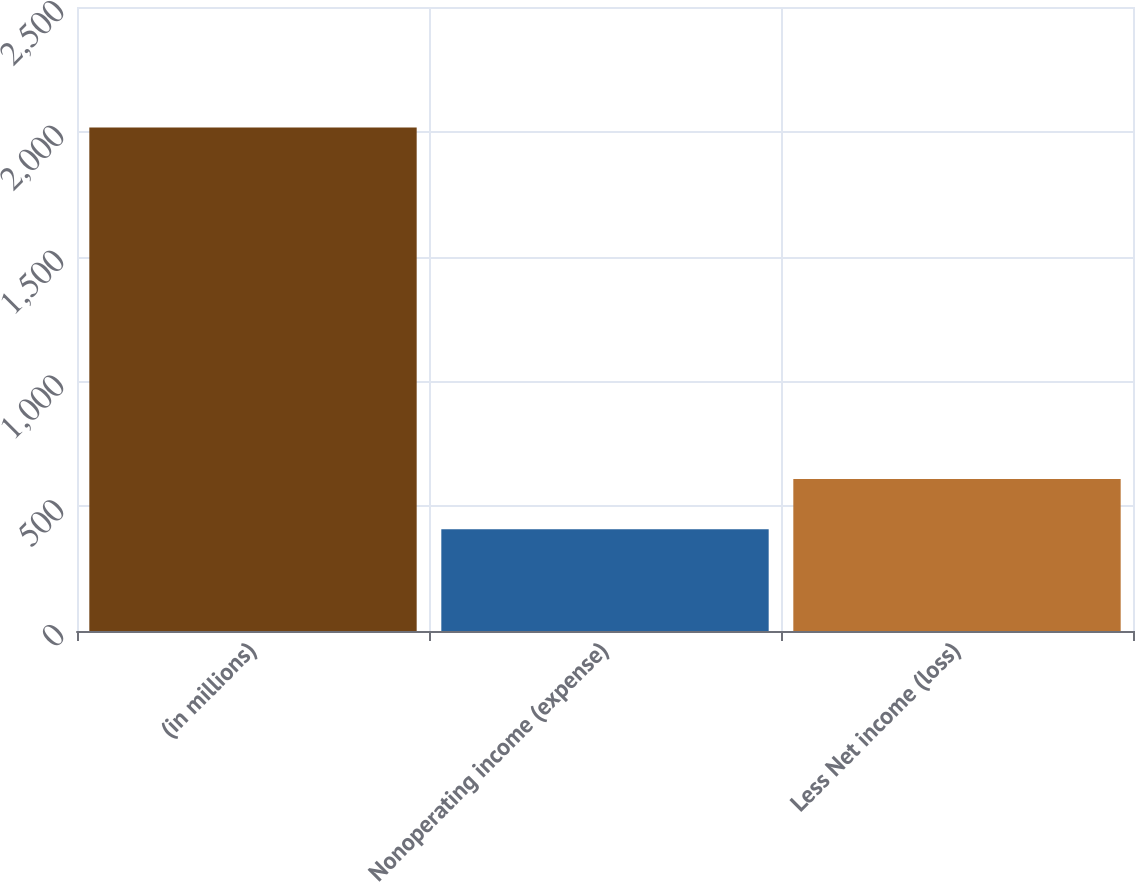Convert chart. <chart><loc_0><loc_0><loc_500><loc_500><bar_chart><fcel>(in millions)<fcel>Nonoperating income (expense)<fcel>Less Net income (loss)<nl><fcel>2017<fcel>407.4<fcel>608.6<nl></chart> 